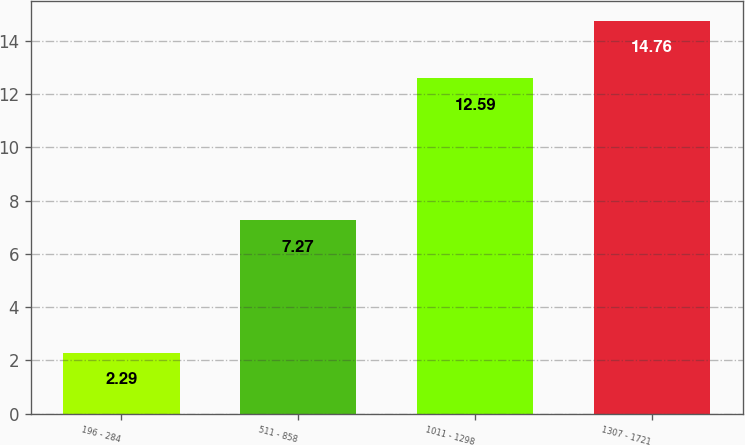<chart> <loc_0><loc_0><loc_500><loc_500><bar_chart><fcel>196 - 284<fcel>511 - 858<fcel>1011 - 1298<fcel>1307 - 1721<nl><fcel>2.29<fcel>7.27<fcel>12.59<fcel>14.76<nl></chart> 